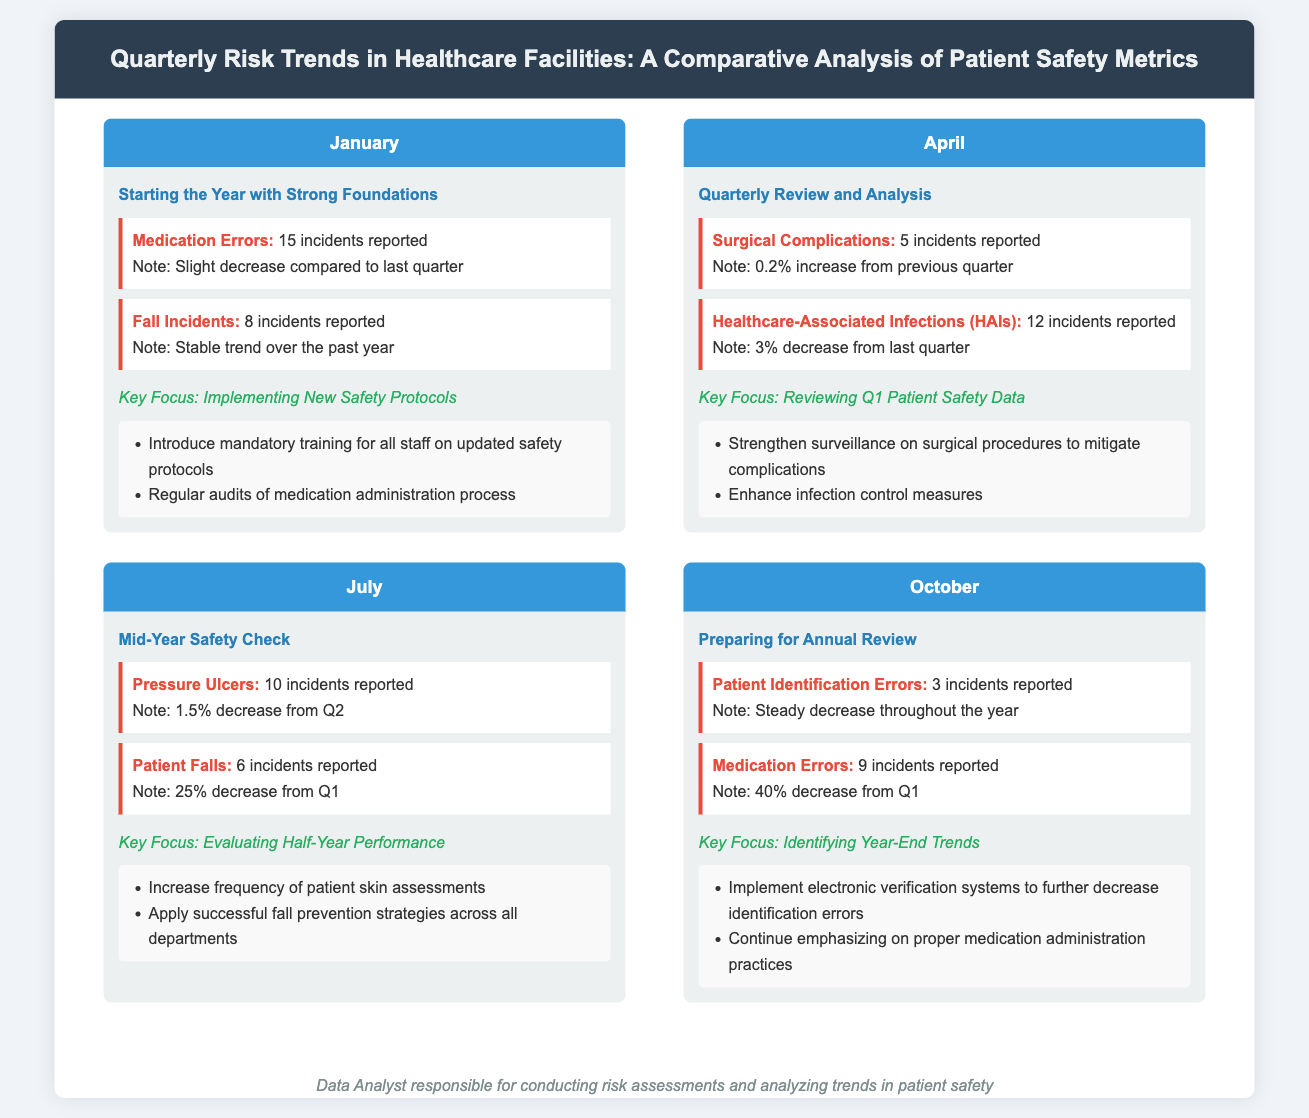What were the medication errors reported in January? January reported 15 incidents of medication errors.
Answer: 15 incidents How many incidents of surgical complications were reported in April? April reported 5 incidents of surgical complications.
Answer: 5 incidents What was the percentage decrease of patient falls from Q1 to July? Patient falls decreased by 25% from Q1 to July.
Answer: 25% What is the key focus for October? The key focus for October is identifying year-end trends.
Answer: Identifying Year-End Trends How many healthcare-associated infections were reported in April? April reported 12 incidents of healthcare-associated infections.
Answer: 12 incidents What is the trend of patient identification errors throughout the year? Patient identification errors show a steady decrease throughout the year.
Answer: Steady decrease What is the recommendation for medication administration in October? The recommendation is to continue emphasizing proper medication administration practices.
Answer: Continue emphasizing on proper medication administration practices What was the total number of fall incidents reported in January? January reported 8 incidents of fall incidents.
Answer: 8 incidents What was the decrease percentage of medication errors from Q1 to October? Medication errors decreased by 40% from Q1 to October.
Answer: 40% 